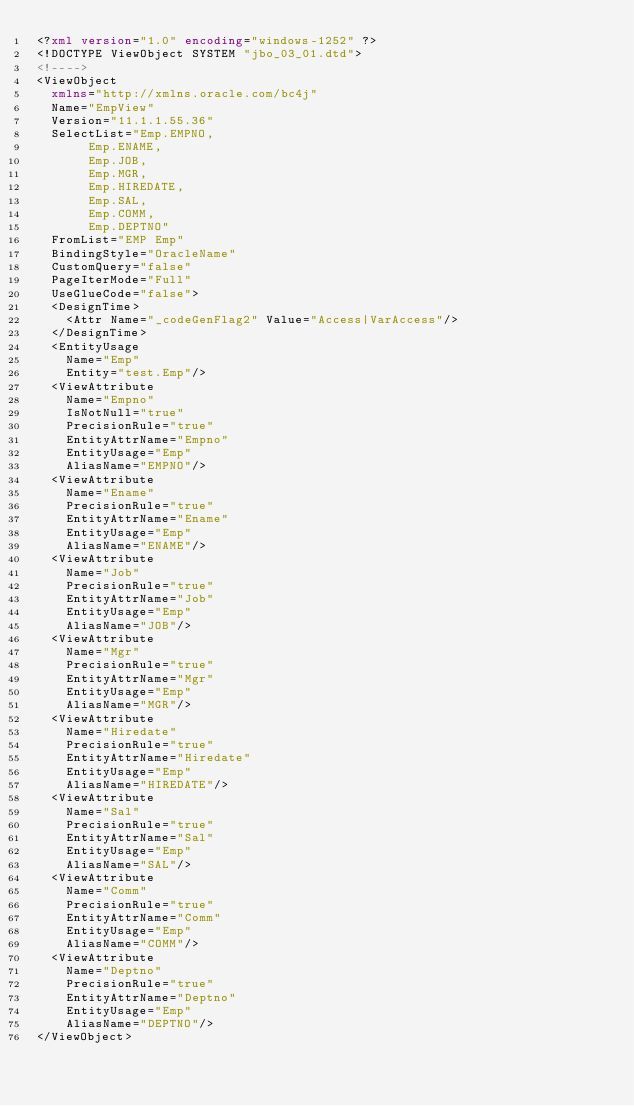<code> <loc_0><loc_0><loc_500><loc_500><_XML_><?xml version="1.0" encoding="windows-1252" ?>
<!DOCTYPE ViewObject SYSTEM "jbo_03_01.dtd">
<!---->
<ViewObject
  xmlns="http://xmlns.oracle.com/bc4j"
  Name="EmpView"
  Version="11.1.1.55.36"
  SelectList="Emp.EMPNO, 
       Emp.ENAME, 
       Emp.JOB, 
       Emp.MGR, 
       Emp.HIREDATE, 
       Emp.SAL, 
       Emp.COMM, 
       Emp.DEPTNO"
  FromList="EMP Emp"
  BindingStyle="OracleName"
  CustomQuery="false"
  PageIterMode="Full"
  UseGlueCode="false">
  <DesignTime>
    <Attr Name="_codeGenFlag2" Value="Access|VarAccess"/>
  </DesignTime>
  <EntityUsage
    Name="Emp"
    Entity="test.Emp"/>
  <ViewAttribute
    Name="Empno"
    IsNotNull="true"
    PrecisionRule="true"
    EntityAttrName="Empno"
    EntityUsage="Emp"
    AliasName="EMPNO"/>
  <ViewAttribute
    Name="Ename"
    PrecisionRule="true"
    EntityAttrName="Ename"
    EntityUsage="Emp"
    AliasName="ENAME"/>
  <ViewAttribute
    Name="Job"
    PrecisionRule="true"
    EntityAttrName="Job"
    EntityUsage="Emp"
    AliasName="JOB"/>
  <ViewAttribute
    Name="Mgr"
    PrecisionRule="true"
    EntityAttrName="Mgr"
    EntityUsage="Emp"
    AliasName="MGR"/>
  <ViewAttribute
    Name="Hiredate"
    PrecisionRule="true"
    EntityAttrName="Hiredate"
    EntityUsage="Emp"
    AliasName="HIREDATE"/>
  <ViewAttribute
    Name="Sal"
    PrecisionRule="true"
    EntityAttrName="Sal"
    EntityUsage="Emp"
    AliasName="SAL"/>
  <ViewAttribute
    Name="Comm"
    PrecisionRule="true"
    EntityAttrName="Comm"
    EntityUsage="Emp"
    AliasName="COMM"/>
  <ViewAttribute
    Name="Deptno"
    PrecisionRule="true"
    EntityAttrName="Deptno"
    EntityUsage="Emp"
    AliasName="DEPTNO"/>
</ViewObject>
</code> 